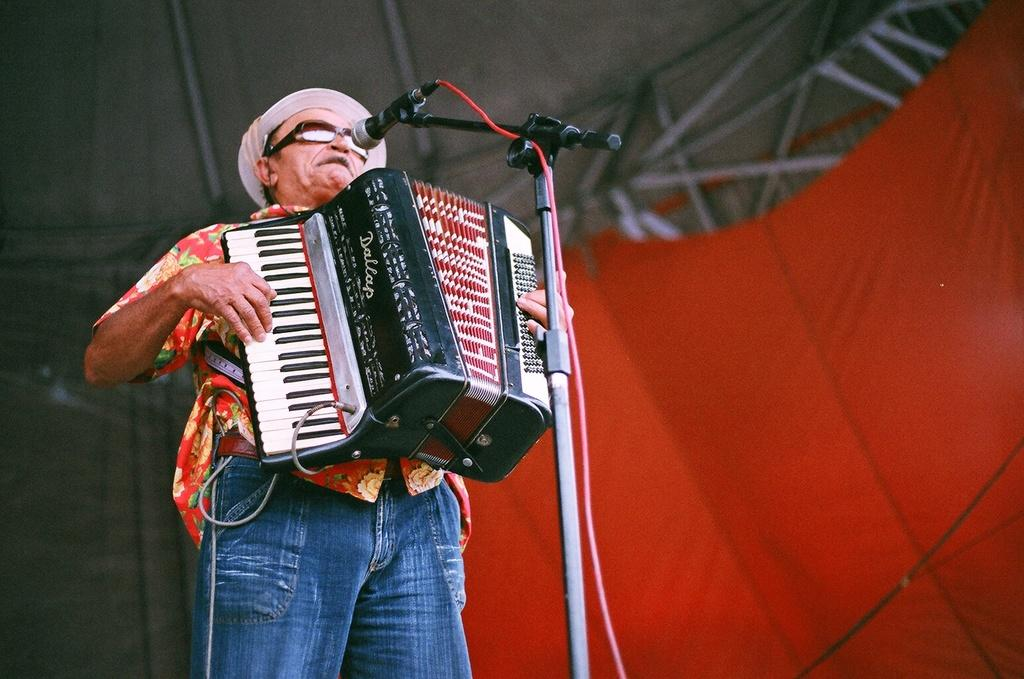What is the main object in the image? There is a mic in the image. What other objects can be seen in the image? There are goggles, a cap, an accordion, and a stand in the image. Can you describe the person in the image? There is a person standing in the image. What can be seen in the background of the image? There is a red cloth and rods in the background of the image. What shape is the person feeling in the image? There is no indication of the person's emotions or feelings in the image, so we cannot determine the shape they might be feeling. 